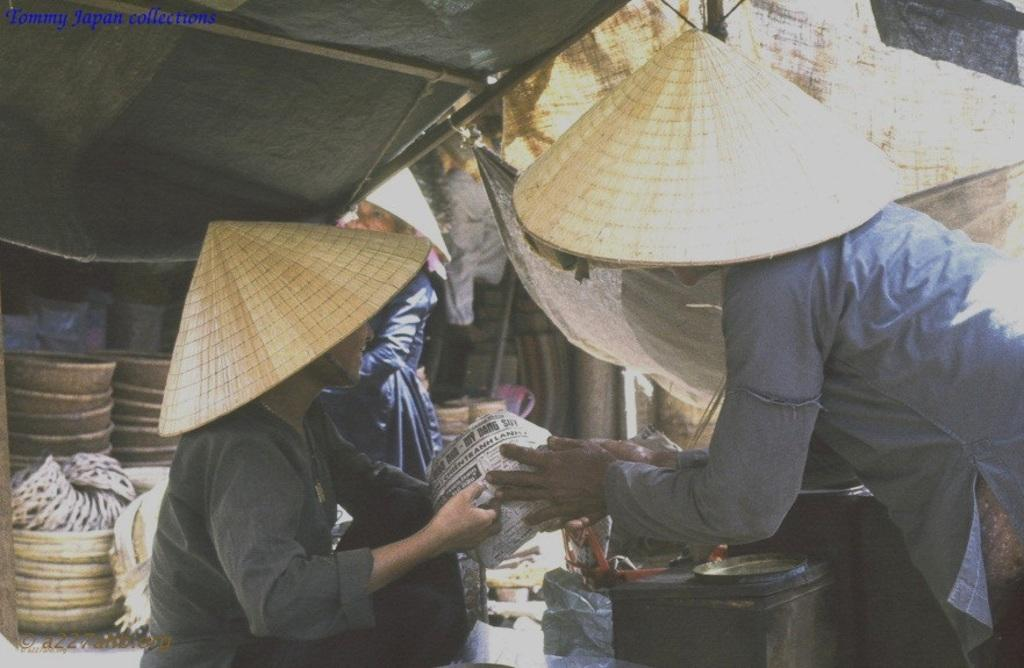What are the people in the image wearing on their heads? There are people wearing hats in the image. What are the people holding in their hands? The people are holding something in the image. What type of containers can be seen in the image? There are baskets in the image. What are the tall, thin structures in the image? There are poles in the image. What objects can be found in the image? There are objects in the image. What type of material is covering some of the objects in the image? There are black color plastic covers in the image. How many eyes can be seen on the playground equipment in the image? There is no playground equipment present in the image, so it is not possible to determine the number of eyes. 